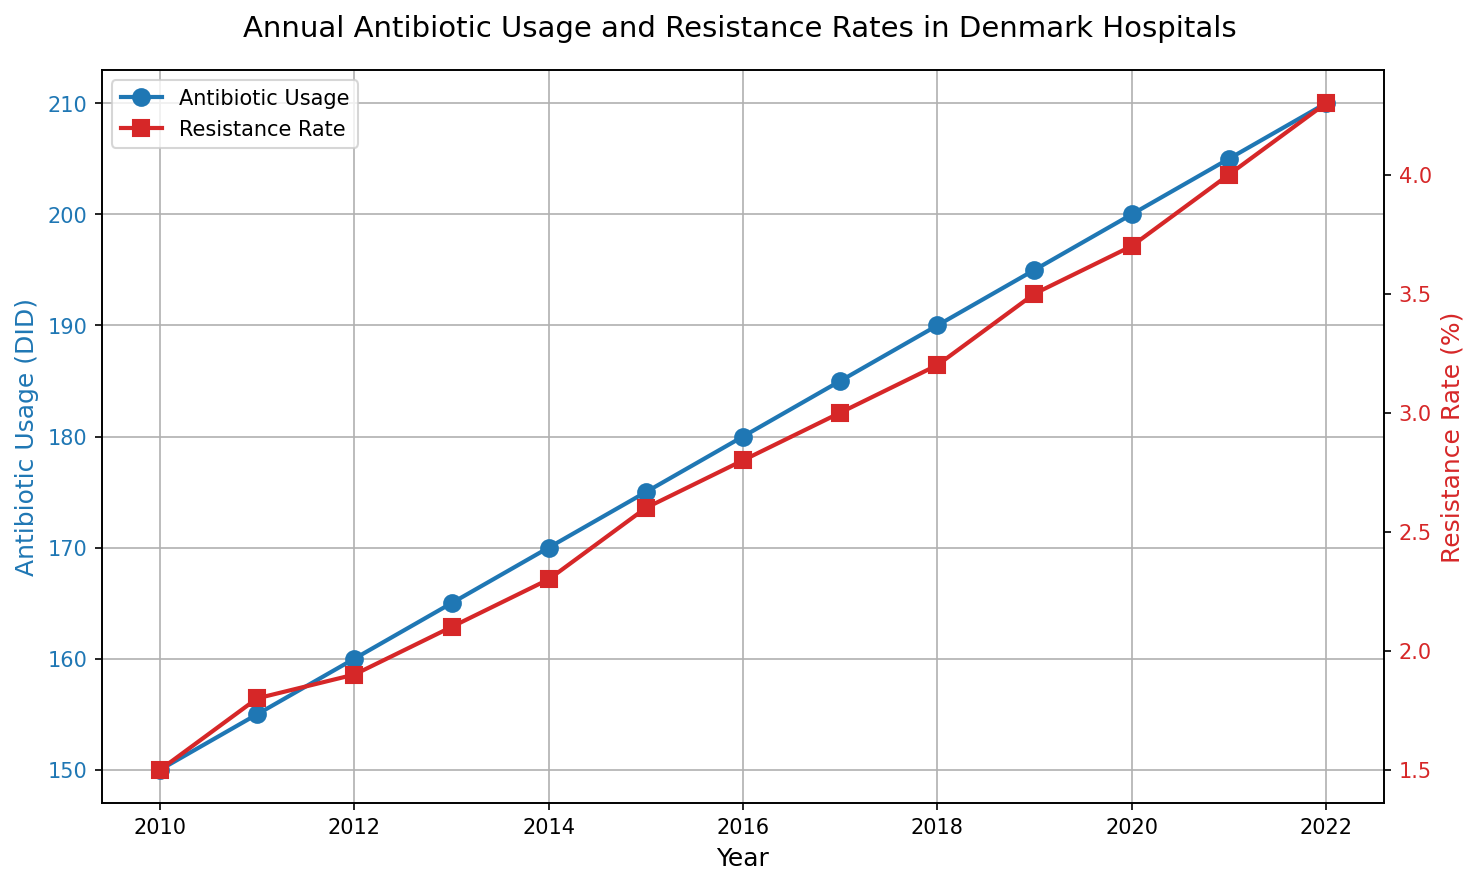What trend is observed in antibiotic usage from 2010 to 2022? The antibiotic usage consistently increases every year from 150 DID in 2010 to 210 DID in 2022.
Answer: Increase Compare the resistance rate in 2012 and 2018. Which year had a higher rate? The resistance rate in 2012 is 1.9%, whereas in 2018 it is 3.2%. 3.2% is greater than 1.9%.
Answer: 2018 What is the average antibiotic usage over the entire period? Summing the antibiotic usage from 2010 to 2022: 150 + 155 + 160 + 165 + 170 + 175 + 180 + 185 + 190 + 195 + 200 + 205 + 210 = 2240. There are 13 years, so the average usage is 2240 / 13.
Answer: 172.31 DID How much did the resistance rate increase from 2010 to 2022? The resistance rate in 2010 is 1.5%, and in 2022 it is 4.3%. The increase is 4.3% - 1.5%.
Answer: 2.8% During which year did the antibiotic usage first reach 200 DID? The antibiotic usage reaches 200 DID in 2020 according to the data.
Answer: 2020 Compare the slope (rate of increase) of antibiotic usage and resistance rate. Which one shows a steeper increase? Visually inspecting the graph, both trends increase linearly but the resistance rate line appears to have a steeper slope due to a higher rate of increase per year.
Answer: Resistance rate What is the difference in antibiotic usage between 2015 and 2022? Antibiotic usage in 2015 is 175 DID and in 2022 is 210 DID. The difference is 210 - 175.
Answer: 35 DID Which data series uses red color in the figure? The resistance rate data series is represented by a red color.
Answer: Resistance rate By how much did the resistance rate change between 2014 and 2021? The resistance rate in 2014 is 2.3%, and in 2021 it is 4.0%. The change is 4.0% - 2.3%.
Answer: 1.7% In what year was the antibiotic usage 155 DID? The antibiotic usage reached 155 DID in the year 2011.
Answer: 2011 